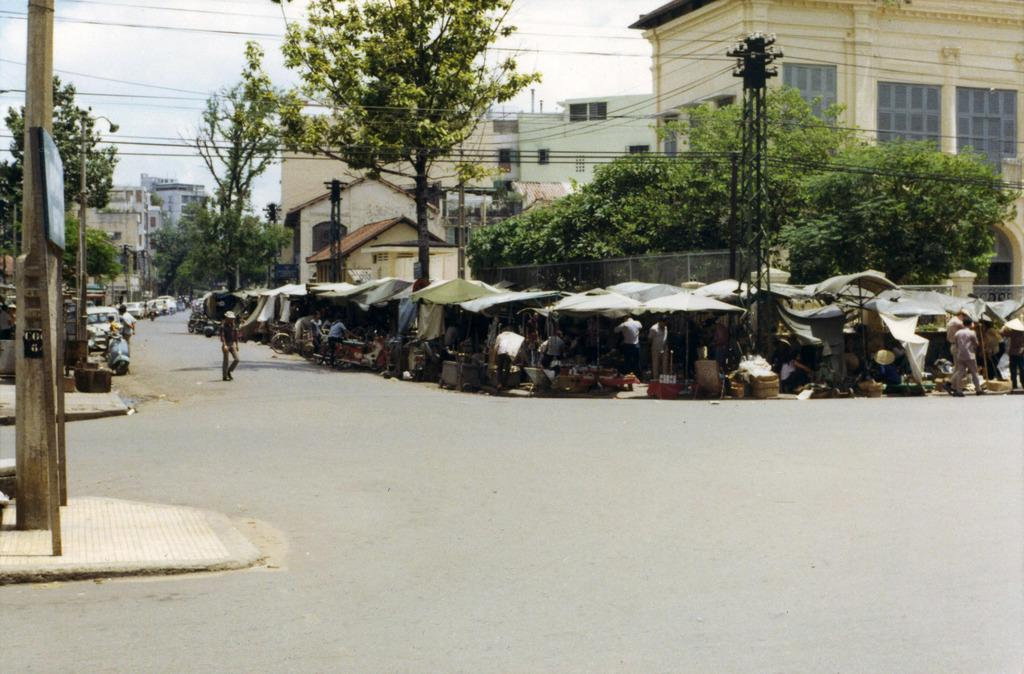What type of structures can be seen in the image? There are roadside stalls in the image. Who or what is present on the road? There are people standing on the road. What type of vegetation is visible in the image? There are trees visible in the image. What type of man-made structures can be seen in the image? There are buildings in the image. How many buns are being sold at the roadside stalls in the image? There is no mention of buns being sold at the roadside stalls in the image. Is there a beggar visible in the image? There is no mention of a beggar in the image. 